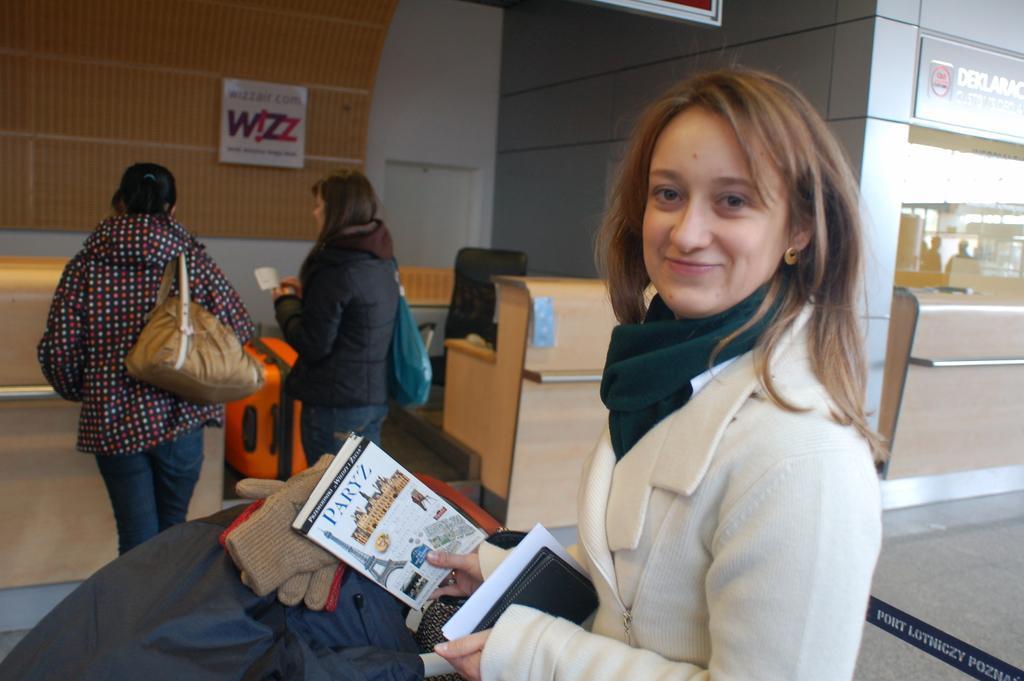Describe this image in one or two sentences. In this image we can see a group of women standing. Two women are carrying bags. One woman is holding a book and paper in her hands. In the foreground we can see a coat and gloves. In the background, we can see a chair, tables, building, sign board with some text and a ribbon 